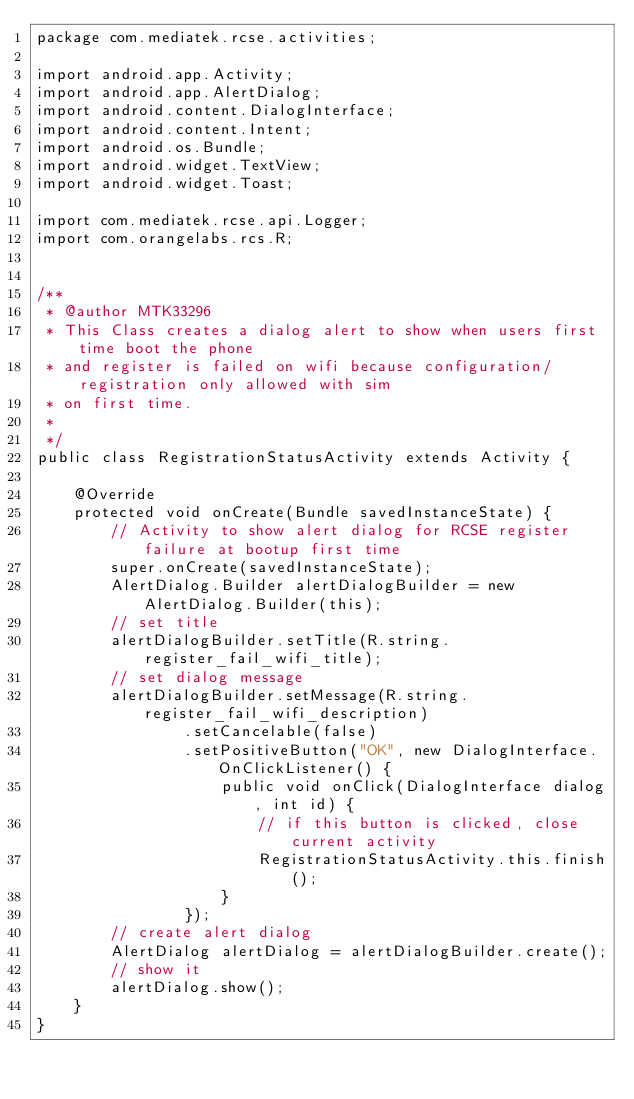Convert code to text. <code><loc_0><loc_0><loc_500><loc_500><_Java_>package com.mediatek.rcse.activities;

import android.app.Activity;
import android.app.AlertDialog;
import android.content.DialogInterface;
import android.content.Intent;
import android.os.Bundle;
import android.widget.TextView;
import android.widget.Toast;

import com.mediatek.rcse.api.Logger;
import com.orangelabs.rcs.R;


/**
 * @author MTK33296
 * This Class creates a dialog alert to show when users first time boot the phone
 * and register is failed on wifi because configuration/registration only allowed with sim
 * on first time.
 *
 */
public class RegistrationStatusActivity extends Activity {

    @Override
    protected void onCreate(Bundle savedInstanceState) {
        // Activity to show alert dialog for RCSE register failure at bootup first time
        super.onCreate(savedInstanceState);
        AlertDialog.Builder alertDialogBuilder = new AlertDialog.Builder(this);
        // set title
        alertDialogBuilder.setTitle(R.string.register_fail_wifi_title);
        // set dialog message
        alertDialogBuilder.setMessage(R.string.register_fail_wifi_description)
                .setCancelable(false)
                .setPositiveButton("OK", new DialogInterface.OnClickListener() {
                    public void onClick(DialogInterface dialog, int id) {
                        // if this button is clicked, close current activity
                        RegistrationStatusActivity.this.finish();
                    }
                });
        // create alert dialog
        AlertDialog alertDialog = alertDialogBuilder.create();
        // show it
        alertDialog.show();
    }
}

</code> 